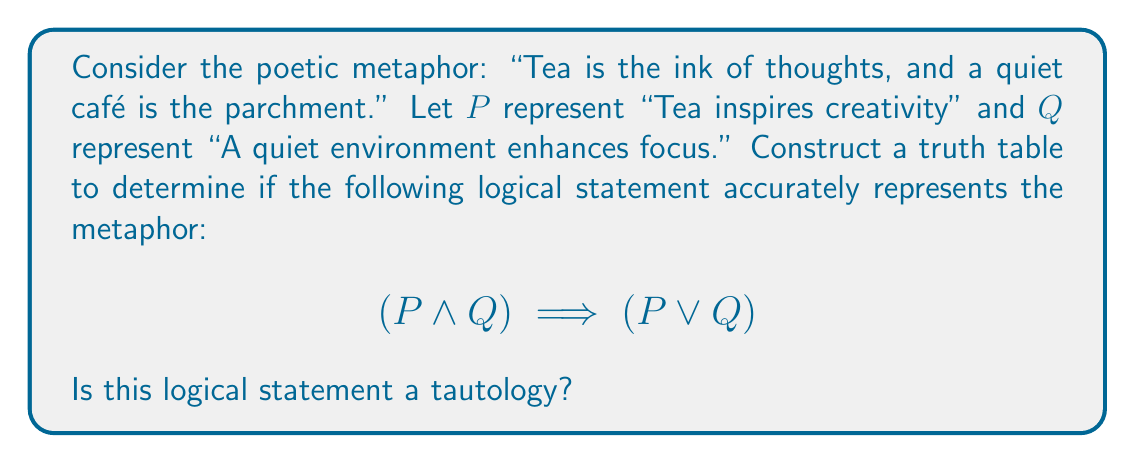What is the answer to this math problem? To determine if the given logical statement is a tautology, we need to construct a truth table and evaluate the statement for all possible combinations of truth values for $P$ and $Q$.

Let's construct the truth table:

1. First, list all possible combinations of truth values for $P$ and $Q$:

   | $P$ | $Q$ |
   |-----|-----|
   |  T  |  T  |
   |  T  |  F  |
   |  F  |  T  |
   |  F  |  F  |

2. Evaluate $(P \land Q)$:

   | $P$ | $Q$ | $(P \land Q)$ |
   |-----|-----|---------------|
   |  T  |  T  |       T       |
   |  T  |  F  |       F       |
   |  F  |  T  |       F       |
   |  F  |  F  |       F       |

3. Evaluate $(P \lor Q)$:

   | $P$ | $Q$ | $(P \lor Q)$ |
   |-----|-----|--------------|
   |  T  |  T  |      T       |
   |  T  |  F  |      T       |
   |  F  |  T  |      T       |
   |  F  |  F  |      F       |

4. Now, evaluate the complete statement $(P \land Q) \implies (P \lor Q)$:

   | $P$ | $Q$ | $(P \land Q)$ | $(P \lor Q)$ | $(P \land Q) \implies (P \lor Q)$ |
   |-----|-----|---------------|--------------|-----------------------------------|
   |  T  |  T  |       T       |      T       |                T                  |
   |  T  |  F  |       F       |      T       |                T                  |
   |  F  |  T  |       F       |      T       |                T                  |
   |  F  |  F  |       F       |      F       |                T                  |

We can see that the result of $(P \land Q) \implies (P \lor Q)$ is true for all possible combinations of $P$ and $Q$.

In logical terms, a statement that is always true, regardless of the truth values of its components, is called a tautology.
Answer: Yes, the logical statement $(P \land Q) \implies (P \lor Q)$ is a tautology, as it evaluates to true for all possible truth values of $P$ and $Q$. This implies that the given poetic metaphor is logically valid according to this representation. 